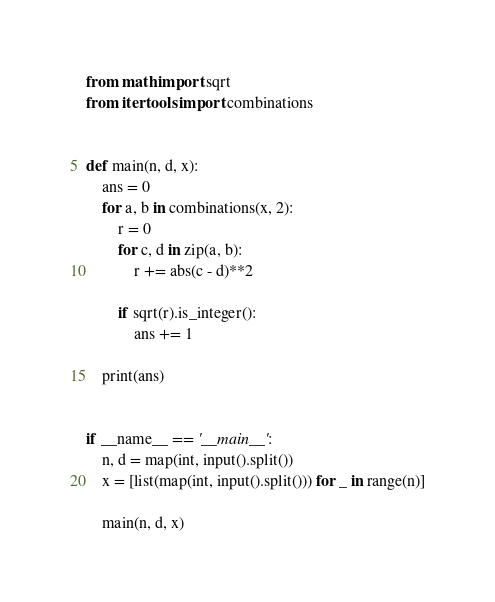<code> <loc_0><loc_0><loc_500><loc_500><_Python_>from math import sqrt
from itertools import combinations


def main(n, d, x):
    ans = 0
    for a, b in combinations(x, 2):
        r = 0
        for c, d in zip(a, b):
            r += abs(c - d)**2

        if sqrt(r).is_integer():
            ans += 1

    print(ans)


if __name__ == '__main__':
    n, d = map(int, input().split())
    x = [list(map(int, input().split())) for _ in range(n)]

    main(n, d, x)
</code> 